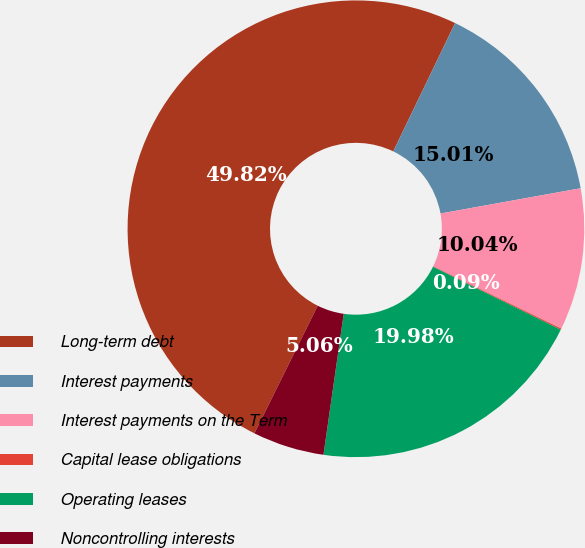<chart> <loc_0><loc_0><loc_500><loc_500><pie_chart><fcel>Long-term debt<fcel>Interest payments<fcel>Interest payments on the Term<fcel>Capital lease obligations<fcel>Operating leases<fcel>Noncontrolling interests<nl><fcel>49.82%<fcel>15.01%<fcel>10.04%<fcel>0.09%<fcel>19.98%<fcel>5.06%<nl></chart> 